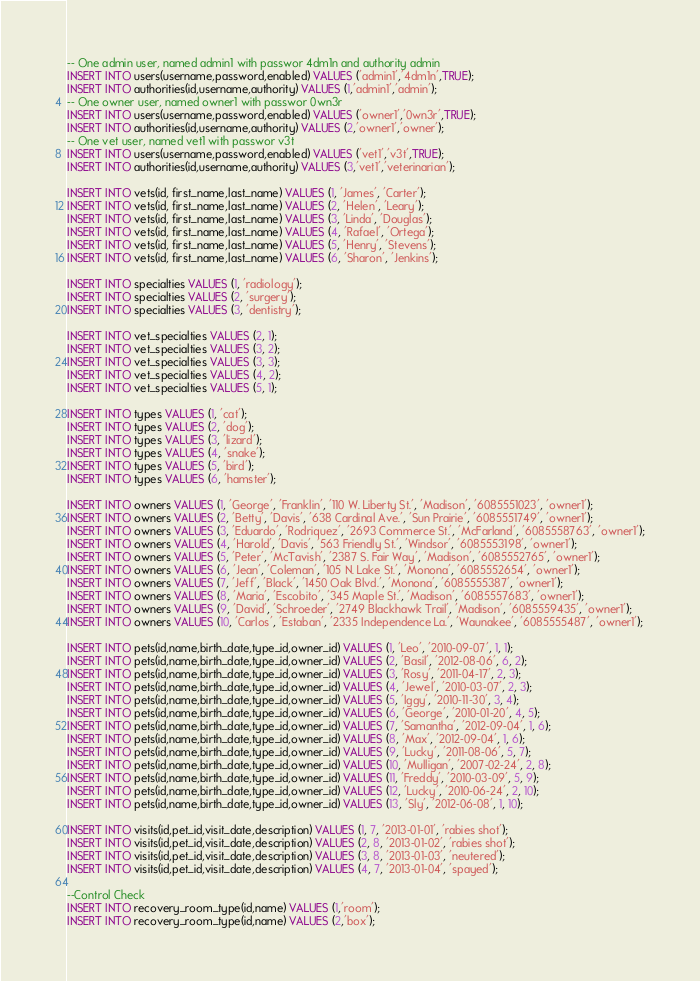<code> <loc_0><loc_0><loc_500><loc_500><_SQL_>-- One admin user, named admin1 with passwor 4dm1n and authority admin
INSERT INTO users(username,password,enabled) VALUES ('admin1','4dm1n',TRUE);
INSERT INTO authorities(id,username,authority) VALUES (1,'admin1','admin');
-- One owner user, named owner1 with passwor 0wn3r
INSERT INTO users(username,password,enabled) VALUES ('owner1','0wn3r',TRUE);
INSERT INTO authorities(id,username,authority) VALUES (2,'owner1','owner');
-- One vet user, named vet1 with passwor v3t
INSERT INTO users(username,password,enabled) VALUES ('vet1','v3t',TRUE);
INSERT INTO authorities(id,username,authority) VALUES (3,'vet1','veterinarian');

INSERT INTO vets(id, first_name,last_name) VALUES (1, 'James', 'Carter');
INSERT INTO vets(id, first_name,last_name) VALUES (2, 'Helen', 'Leary');
INSERT INTO vets(id, first_name,last_name) VALUES (3, 'Linda', 'Douglas');
INSERT INTO vets(id, first_name,last_name) VALUES (4, 'Rafael', 'Ortega');
INSERT INTO vets(id, first_name,last_name) VALUES (5, 'Henry', 'Stevens');
INSERT INTO vets(id, first_name,last_name) VALUES (6, 'Sharon', 'Jenkins');

INSERT INTO specialties VALUES (1, 'radiology');
INSERT INTO specialties VALUES (2, 'surgery');
INSERT INTO specialties VALUES (3, 'dentistry');

INSERT INTO vet_specialties VALUES (2, 1);
INSERT INTO vet_specialties VALUES (3, 2);
INSERT INTO vet_specialties VALUES (3, 3);
INSERT INTO vet_specialties VALUES (4, 2);
INSERT INTO vet_specialties VALUES (5, 1);

INSERT INTO types VALUES (1, 'cat');
INSERT INTO types VALUES (2, 'dog');
INSERT INTO types VALUES (3, 'lizard');
INSERT INTO types VALUES (4, 'snake');
INSERT INTO types VALUES (5, 'bird');
INSERT INTO types VALUES (6, 'hamster');

INSERT INTO owners VALUES (1, 'George', 'Franklin', '110 W. Liberty St.', 'Madison', '6085551023', 'owner1');
INSERT INTO owners VALUES (2, 'Betty', 'Davis', '638 Cardinal Ave.', 'Sun Prairie', '6085551749', 'owner1');
INSERT INTO owners VALUES (3, 'Eduardo', 'Rodriquez', '2693 Commerce St.', 'McFarland', '6085558763', 'owner1');
INSERT INTO owners VALUES (4, 'Harold', 'Davis', '563 Friendly St.', 'Windsor', '6085553198', 'owner1');
INSERT INTO owners VALUES (5, 'Peter', 'McTavish', '2387 S. Fair Way', 'Madison', '6085552765', 'owner1');
INSERT INTO owners VALUES (6, 'Jean', 'Coleman', '105 N. Lake St.', 'Monona', '6085552654', 'owner1');
INSERT INTO owners VALUES (7, 'Jeff', 'Black', '1450 Oak Blvd.', 'Monona', '6085555387', 'owner1');
INSERT INTO owners VALUES (8, 'Maria', 'Escobito', '345 Maple St.', 'Madison', '6085557683', 'owner1');
INSERT INTO owners VALUES (9, 'David', 'Schroeder', '2749 Blackhawk Trail', 'Madison', '6085559435', 'owner1');
INSERT INTO owners VALUES (10, 'Carlos', 'Estaban', '2335 Independence La.', 'Waunakee', '6085555487', 'owner1');

INSERT INTO pets(id,name,birth_date,type_id,owner_id) VALUES (1, 'Leo', '2010-09-07', 1, 1);
INSERT INTO pets(id,name,birth_date,type_id,owner_id) VALUES (2, 'Basil', '2012-08-06', 6, 2);
INSERT INTO pets(id,name,birth_date,type_id,owner_id) VALUES (3, 'Rosy', '2011-04-17', 2, 3);
INSERT INTO pets(id,name,birth_date,type_id,owner_id) VALUES (4, 'Jewel', '2010-03-07', 2, 3);
INSERT INTO pets(id,name,birth_date,type_id,owner_id) VALUES (5, 'Iggy', '2010-11-30', 3, 4);
INSERT INTO pets(id,name,birth_date,type_id,owner_id) VALUES (6, 'George', '2010-01-20', 4, 5);
INSERT INTO pets(id,name,birth_date,type_id,owner_id) VALUES (7, 'Samantha', '2012-09-04', 1, 6);
INSERT INTO pets(id,name,birth_date,type_id,owner_id) VALUES (8, 'Max', '2012-09-04', 1, 6);
INSERT INTO pets(id,name,birth_date,type_id,owner_id) VALUES (9, 'Lucky', '2011-08-06', 5, 7);
INSERT INTO pets(id,name,birth_date,type_id,owner_id) VALUES (10, 'Mulligan', '2007-02-24', 2, 8);
INSERT INTO pets(id,name,birth_date,type_id,owner_id) VALUES (11, 'Freddy', '2010-03-09', 5, 9);
INSERT INTO pets(id,name,birth_date,type_id,owner_id) VALUES (12, 'Lucky', '2010-06-24', 2, 10);
INSERT INTO pets(id,name,birth_date,type_id,owner_id) VALUES (13, 'Sly', '2012-06-08', 1, 10);

INSERT INTO visits(id,pet_id,visit_date,description) VALUES (1, 7, '2013-01-01', 'rabies shot');
INSERT INTO visits(id,pet_id,visit_date,description) VALUES (2, 8, '2013-01-02', 'rabies shot');
INSERT INTO visits(id,pet_id,visit_date,description) VALUES (3, 8, '2013-01-03', 'neutered');
INSERT INTO visits(id,pet_id,visit_date,description) VALUES (4, 7, '2013-01-04', 'spayed');

--Control Check
INSERT INTO recovery_room_type(id,name) VALUES (1,'room');
INSERT INTO recovery_room_type(id,name) VALUES (2,'box');
</code> 